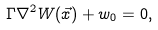<formula> <loc_0><loc_0><loc_500><loc_500>\Gamma \nabla ^ { 2 } W ( \vec { x } ) + w _ { 0 } = 0 ,</formula> 